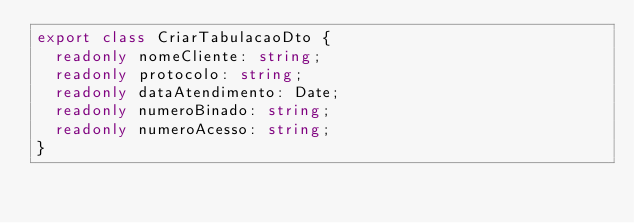Convert code to text. <code><loc_0><loc_0><loc_500><loc_500><_TypeScript_>export class CriarTabulacaoDto {
  readonly nomeCliente: string;
  readonly protocolo: string;
  readonly dataAtendimento: Date;
  readonly numeroBinado: string;
  readonly numeroAcesso: string;
}</code> 